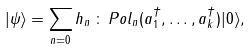<formula> <loc_0><loc_0><loc_500><loc_500>| \psi \rangle = \sum _ { n = 0 } h _ { n } \, \colon \, P o l _ { n } ( a _ { 1 } ^ { \dag } , \dots , a _ { k } ^ { \dag } ) | 0 \rangle ,</formula> 